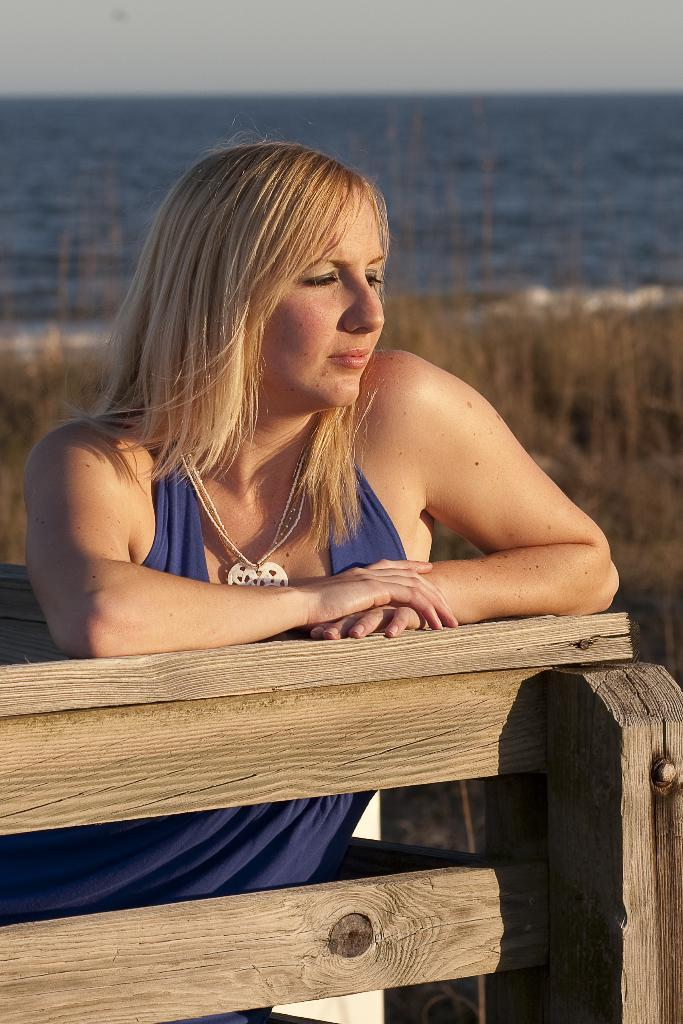What is the person in the image doing? There is a person sitting on a bench in the image. What can be seen in the background of the image? There are many plants and the sea visible in the image. What is visible at the top of the image? The sky is visible at the top of the image. How many balls are being juggled by the lizards in the image? There are no lizards or balls present in the image. 